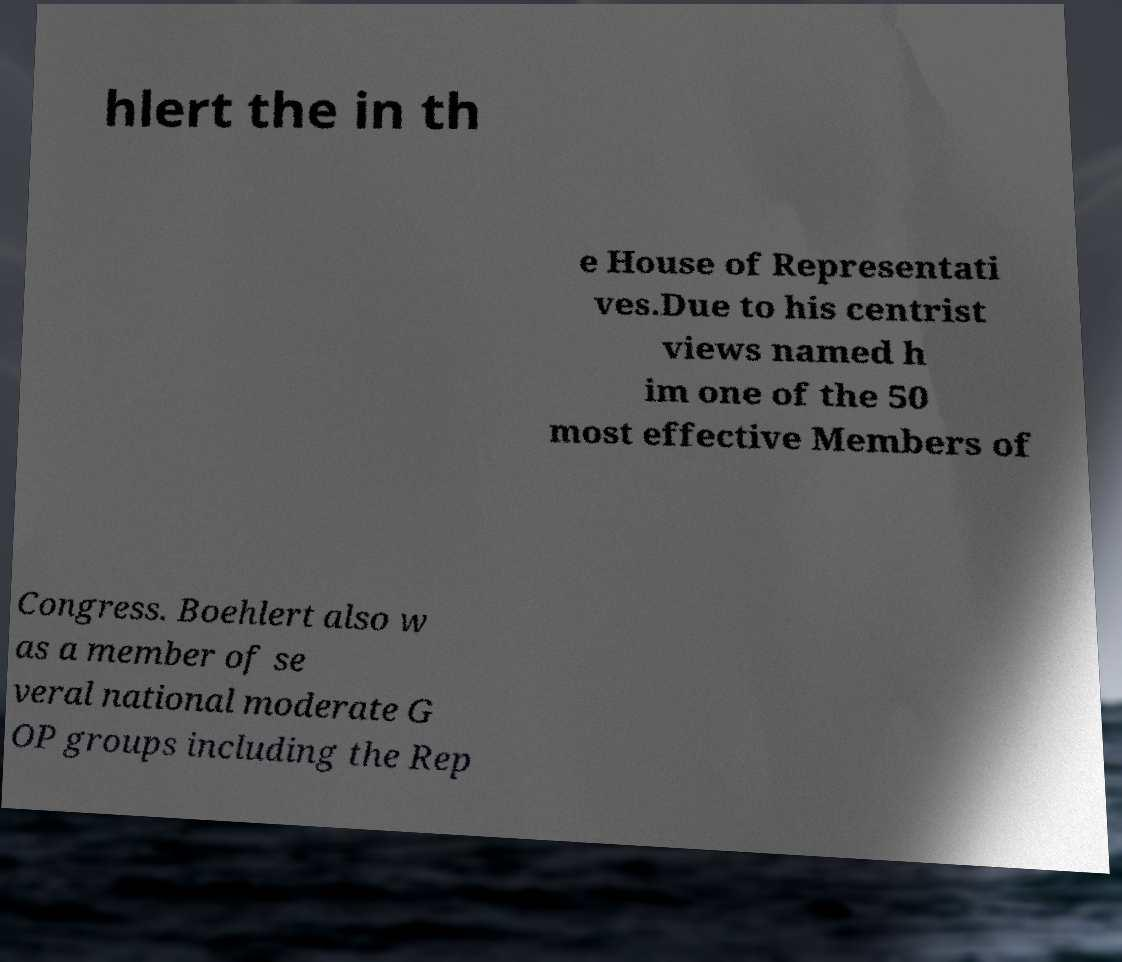Can you read and provide the text displayed in the image?This photo seems to have some interesting text. Can you extract and type it out for me? hlert the in th e House of Representati ves.Due to his centrist views named h im one of the 50 most effective Members of Congress. Boehlert also w as a member of se veral national moderate G OP groups including the Rep 